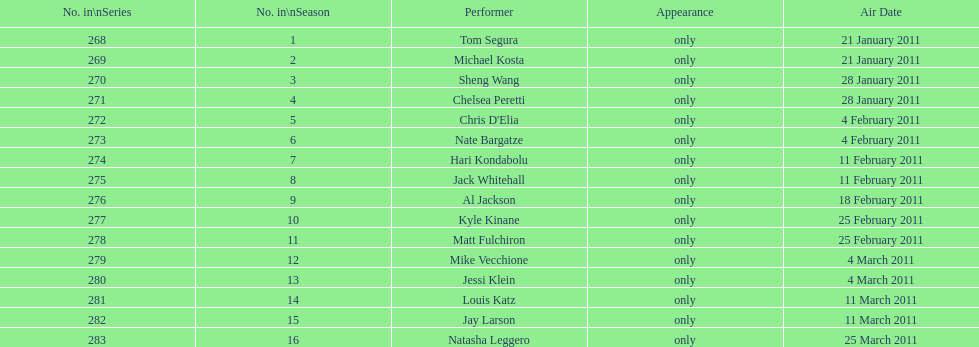In which month were there the most broadcast dates? February. 